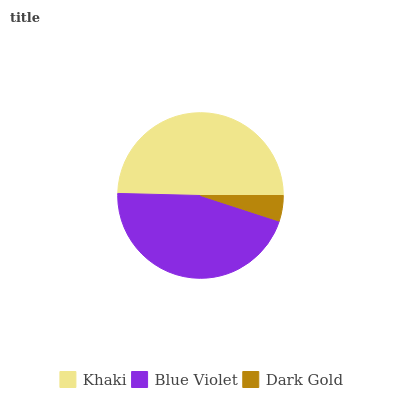Is Dark Gold the minimum?
Answer yes or no. Yes. Is Khaki the maximum?
Answer yes or no. Yes. Is Blue Violet the minimum?
Answer yes or no. No. Is Blue Violet the maximum?
Answer yes or no. No. Is Khaki greater than Blue Violet?
Answer yes or no. Yes. Is Blue Violet less than Khaki?
Answer yes or no. Yes. Is Blue Violet greater than Khaki?
Answer yes or no. No. Is Khaki less than Blue Violet?
Answer yes or no. No. Is Blue Violet the high median?
Answer yes or no. Yes. Is Blue Violet the low median?
Answer yes or no. Yes. Is Khaki the high median?
Answer yes or no. No. Is Khaki the low median?
Answer yes or no. No. 